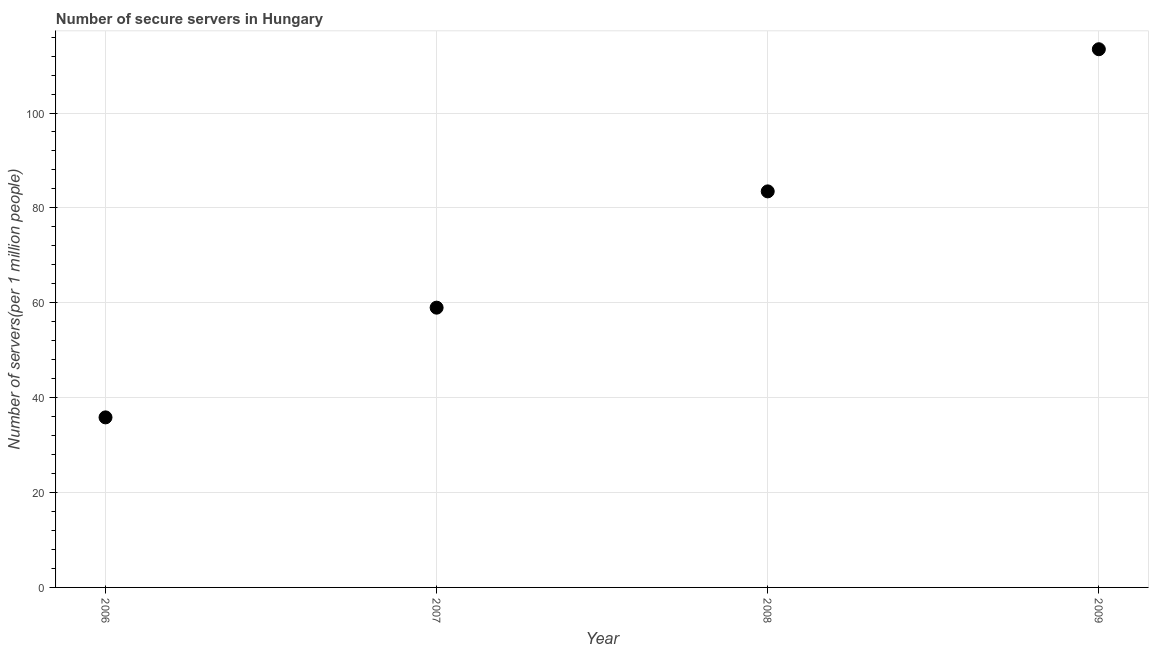What is the number of secure internet servers in 2007?
Keep it short and to the point. 58.97. Across all years, what is the maximum number of secure internet servers?
Ensure brevity in your answer.  113.44. Across all years, what is the minimum number of secure internet servers?
Keep it short and to the point. 35.84. In which year was the number of secure internet servers maximum?
Ensure brevity in your answer.  2009. What is the sum of the number of secure internet servers?
Provide a short and direct response. 291.74. What is the difference between the number of secure internet servers in 2006 and 2008?
Make the answer very short. -47.64. What is the average number of secure internet servers per year?
Provide a succinct answer. 72.93. What is the median number of secure internet servers?
Your response must be concise. 71.23. In how many years, is the number of secure internet servers greater than 80 ?
Keep it short and to the point. 2. Do a majority of the years between 2009 and 2007 (inclusive) have number of secure internet servers greater than 112 ?
Your response must be concise. No. What is the ratio of the number of secure internet servers in 2006 to that in 2007?
Offer a terse response. 0.61. Is the number of secure internet servers in 2008 less than that in 2009?
Provide a succinct answer. Yes. Is the difference between the number of secure internet servers in 2008 and 2009 greater than the difference between any two years?
Offer a terse response. No. What is the difference between the highest and the second highest number of secure internet servers?
Ensure brevity in your answer.  29.96. Is the sum of the number of secure internet servers in 2007 and 2008 greater than the maximum number of secure internet servers across all years?
Make the answer very short. Yes. What is the difference between the highest and the lowest number of secure internet servers?
Offer a terse response. 77.6. What is the title of the graph?
Your response must be concise. Number of secure servers in Hungary. What is the label or title of the Y-axis?
Your answer should be very brief. Number of servers(per 1 million people). What is the Number of servers(per 1 million people) in 2006?
Your response must be concise. 35.84. What is the Number of servers(per 1 million people) in 2007?
Ensure brevity in your answer.  58.97. What is the Number of servers(per 1 million people) in 2008?
Offer a very short reply. 83.48. What is the Number of servers(per 1 million people) in 2009?
Your answer should be compact. 113.44. What is the difference between the Number of servers(per 1 million people) in 2006 and 2007?
Give a very brief answer. -23.13. What is the difference between the Number of servers(per 1 million people) in 2006 and 2008?
Make the answer very short. -47.64. What is the difference between the Number of servers(per 1 million people) in 2006 and 2009?
Ensure brevity in your answer.  -77.6. What is the difference between the Number of servers(per 1 million people) in 2007 and 2008?
Keep it short and to the point. -24.51. What is the difference between the Number of servers(per 1 million people) in 2007 and 2009?
Make the answer very short. -54.47. What is the difference between the Number of servers(per 1 million people) in 2008 and 2009?
Ensure brevity in your answer.  -29.96. What is the ratio of the Number of servers(per 1 million people) in 2006 to that in 2007?
Your response must be concise. 0.61. What is the ratio of the Number of servers(per 1 million people) in 2006 to that in 2008?
Offer a terse response. 0.43. What is the ratio of the Number of servers(per 1 million people) in 2006 to that in 2009?
Keep it short and to the point. 0.32. What is the ratio of the Number of servers(per 1 million people) in 2007 to that in 2008?
Offer a terse response. 0.71. What is the ratio of the Number of servers(per 1 million people) in 2007 to that in 2009?
Your answer should be compact. 0.52. What is the ratio of the Number of servers(per 1 million people) in 2008 to that in 2009?
Provide a succinct answer. 0.74. 